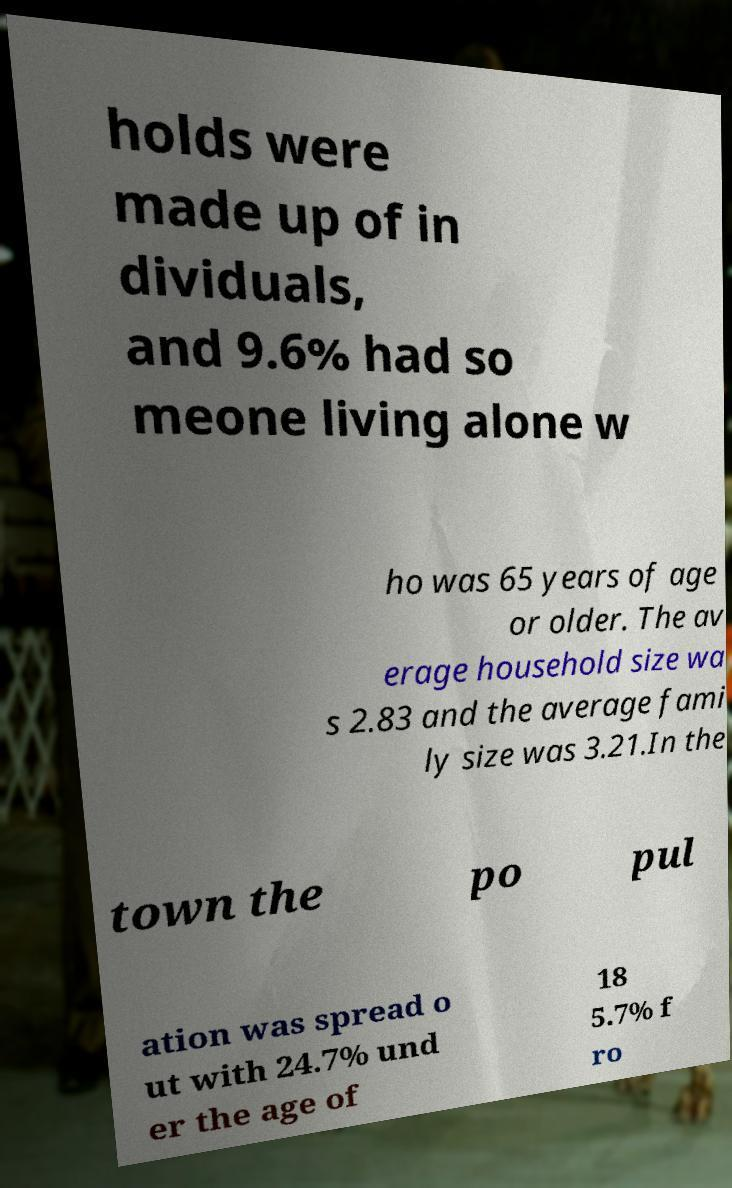Please identify and transcribe the text found in this image. holds were made up of in dividuals, and 9.6% had so meone living alone w ho was 65 years of age or older. The av erage household size wa s 2.83 and the average fami ly size was 3.21.In the town the po pul ation was spread o ut with 24.7% und er the age of 18 5.7% f ro 